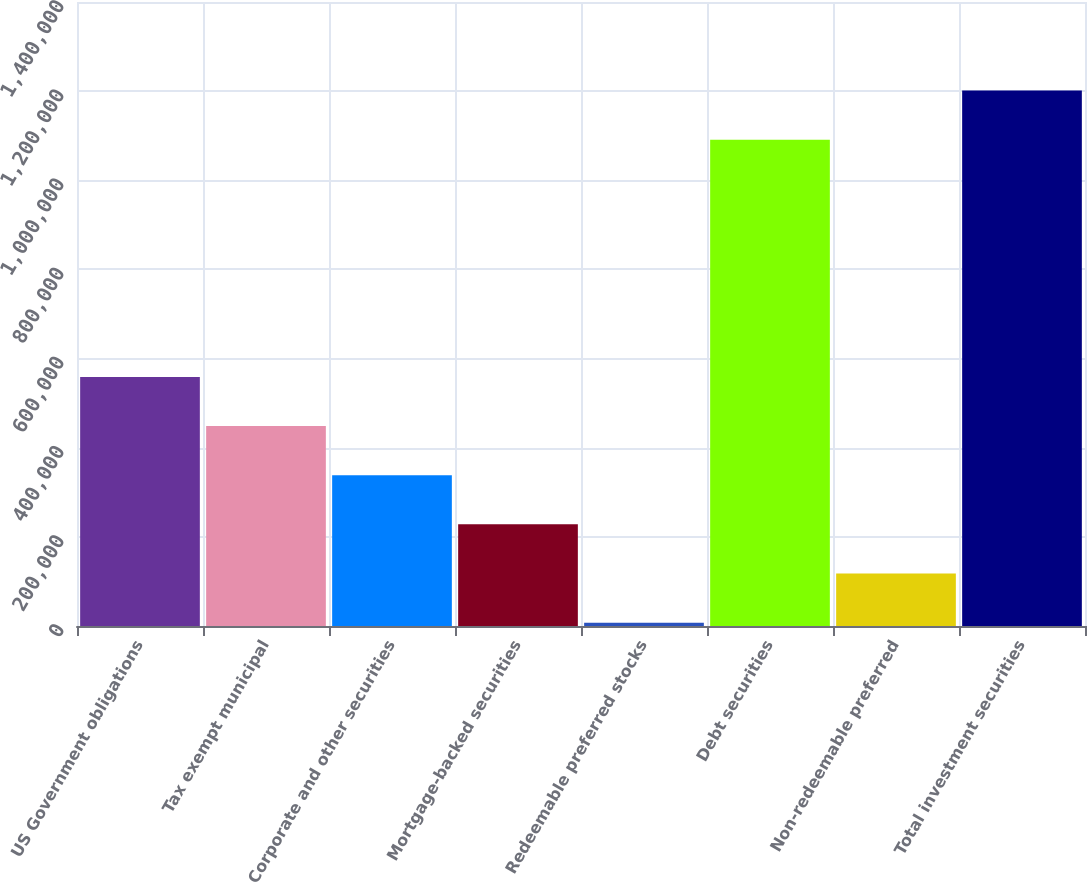<chart> <loc_0><loc_0><loc_500><loc_500><bar_chart><fcel>US Government obligations<fcel>Tax exempt municipal<fcel>Corporate and other securities<fcel>Mortgage-backed securities<fcel>Redeemable preferred stocks<fcel>Debt securities<fcel>Non-redeemable preferred<fcel>Total investment securities<nl><fcel>558904<fcel>448624<fcel>338344<fcel>228064<fcel>7504<fcel>1.09106e+06<fcel>117784<fcel>1.20134e+06<nl></chart> 